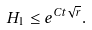Convert formula to latex. <formula><loc_0><loc_0><loc_500><loc_500>H _ { 1 } \leq e ^ { C t \sqrt { r } } .</formula> 